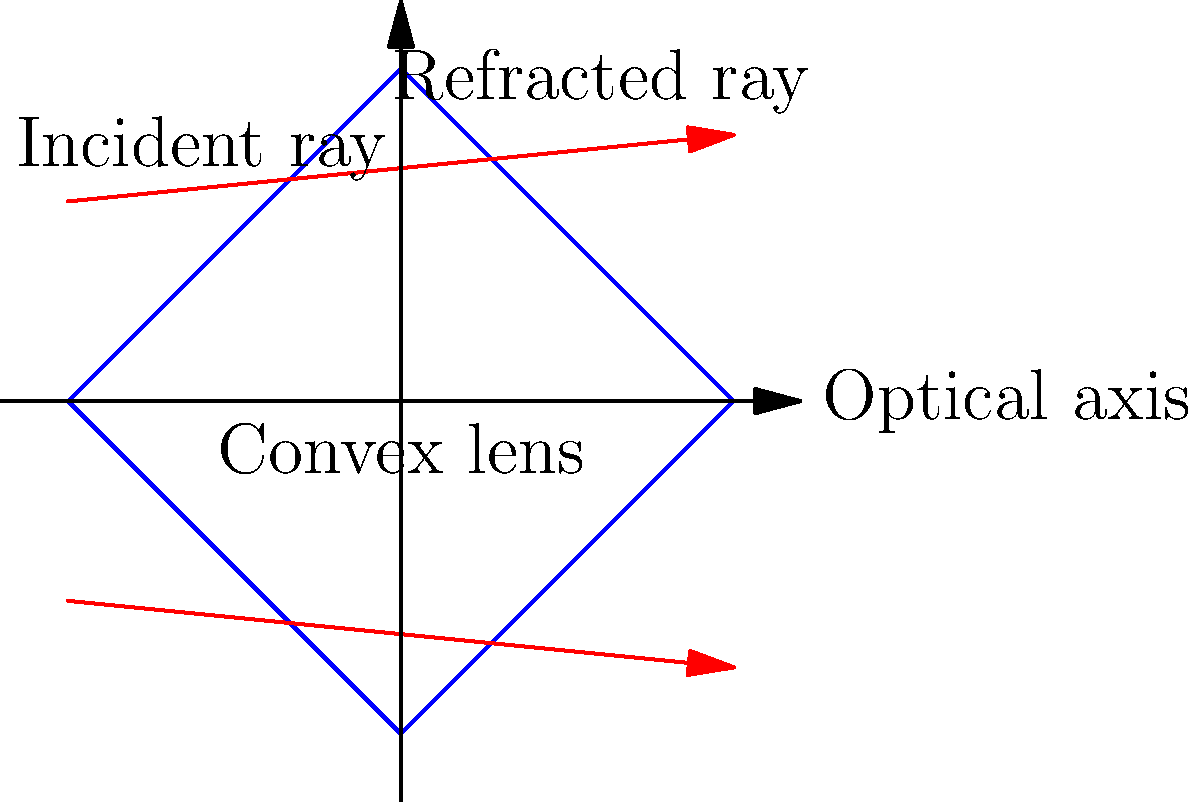In pediatric optometry, convex lenses are commonly used to correct farsightedness (hyperopia) in children. Consider a convex lens with a focal length of 20 cm. If an object is placed 30 cm from the lens, at what distance from the lens will the image be formed? How will this affect the child's vision correction? To solve this problem, we'll use the thin lens equation and follow these steps:

1) The thin lens equation is:
   $$\frac{1}{f} = \frac{1}{d_o} + \frac{1}{d_i}$$
   where $f$ is the focal length, $d_o$ is the object distance, and $d_i$ is the image distance.

2) We're given:
   $f = 20$ cm
   $d_o = 30$ cm

3) Substituting these values into the equation:
   $$\frac{1}{20} = \frac{1}{30} + \frac{1}{d_i}$$

4) Simplify:
   $$0.05 = 0.0333 + \frac{1}{d_i}$$

5) Solve for $\frac{1}{d_i}$:
   $$\frac{1}{d_i} = 0.05 - 0.0333 = 0.0167$$

6) Take the reciprocal to find $d_i$:
   $$d_i = \frac{1}{0.0167} = 60 \text{ cm}$$

7) The image will be formed 60 cm from the lens on the opposite side from the object.

8) This positive image distance indicates that the image is real and inverted.

9) For vision correction, this means the convex lens is converging the light rays to form a clear image on the retina, compensating for the child's farsightedness by increasing the eye's focusing power.
Answer: 60 cm; forms clear image on retina 